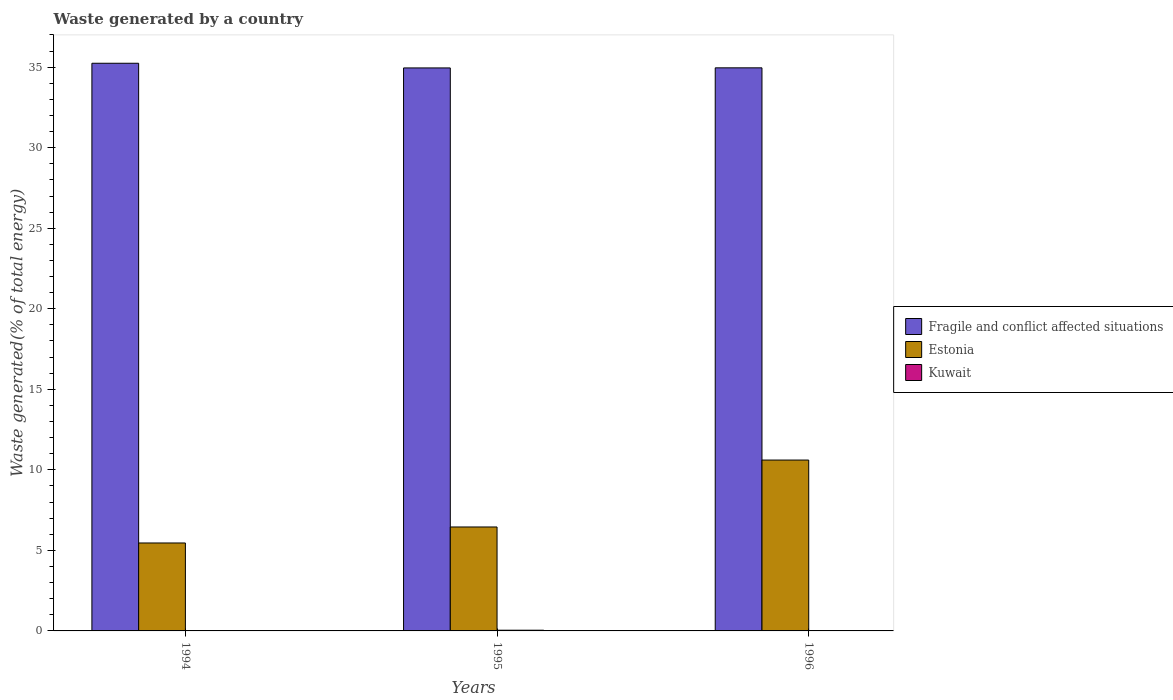Are the number of bars on each tick of the X-axis equal?
Offer a terse response. Yes. In how many cases, is the number of bars for a given year not equal to the number of legend labels?
Give a very brief answer. 0. What is the total waste generated in Fragile and conflict affected situations in 1994?
Your response must be concise. 35.24. Across all years, what is the maximum total waste generated in Fragile and conflict affected situations?
Offer a terse response. 35.24. Across all years, what is the minimum total waste generated in Fragile and conflict affected situations?
Ensure brevity in your answer.  34.95. In which year was the total waste generated in Kuwait minimum?
Your response must be concise. 1994. What is the total total waste generated in Fragile and conflict affected situations in the graph?
Provide a succinct answer. 105.15. What is the difference between the total waste generated in Fragile and conflict affected situations in 1995 and that in 1996?
Keep it short and to the point. -0.01. What is the difference between the total waste generated in Fragile and conflict affected situations in 1996 and the total waste generated in Kuwait in 1994?
Your answer should be compact. 34.94. What is the average total waste generated in Fragile and conflict affected situations per year?
Offer a very short reply. 35.05. In the year 1996, what is the difference between the total waste generated in Estonia and total waste generated in Kuwait?
Provide a short and direct response. 10.58. In how many years, is the total waste generated in Fragile and conflict affected situations greater than 31 %?
Your response must be concise. 3. What is the ratio of the total waste generated in Estonia in 1994 to that in 1996?
Give a very brief answer. 0.51. What is the difference between the highest and the second highest total waste generated in Kuwait?
Offer a very short reply. 0.02. What is the difference between the highest and the lowest total waste generated in Kuwait?
Your answer should be compact. 0.03. In how many years, is the total waste generated in Kuwait greater than the average total waste generated in Kuwait taken over all years?
Your answer should be very brief. 1. What does the 3rd bar from the left in 1996 represents?
Your answer should be compact. Kuwait. What does the 2nd bar from the right in 1996 represents?
Give a very brief answer. Estonia. How many years are there in the graph?
Your answer should be compact. 3. Are the values on the major ticks of Y-axis written in scientific E-notation?
Your answer should be very brief. No. Does the graph contain any zero values?
Offer a very short reply. No. Does the graph contain grids?
Your answer should be compact. No. How many legend labels are there?
Give a very brief answer. 3. What is the title of the graph?
Ensure brevity in your answer.  Waste generated by a country. What is the label or title of the Y-axis?
Make the answer very short. Waste generated(% of total energy). What is the Waste generated(% of total energy) of Fragile and conflict affected situations in 1994?
Give a very brief answer. 35.24. What is the Waste generated(% of total energy) of Estonia in 1994?
Make the answer very short. 5.46. What is the Waste generated(% of total energy) of Kuwait in 1994?
Give a very brief answer. 0.02. What is the Waste generated(% of total energy) in Fragile and conflict affected situations in 1995?
Ensure brevity in your answer.  34.95. What is the Waste generated(% of total energy) of Estonia in 1995?
Your response must be concise. 6.45. What is the Waste generated(% of total energy) in Kuwait in 1995?
Give a very brief answer. 0.04. What is the Waste generated(% of total energy) in Fragile and conflict affected situations in 1996?
Offer a very short reply. 34.96. What is the Waste generated(% of total energy) of Estonia in 1996?
Ensure brevity in your answer.  10.61. What is the Waste generated(% of total energy) in Kuwait in 1996?
Make the answer very short. 0.03. Across all years, what is the maximum Waste generated(% of total energy) of Fragile and conflict affected situations?
Offer a terse response. 35.24. Across all years, what is the maximum Waste generated(% of total energy) of Estonia?
Your response must be concise. 10.61. Across all years, what is the maximum Waste generated(% of total energy) of Kuwait?
Your response must be concise. 0.04. Across all years, what is the minimum Waste generated(% of total energy) in Fragile and conflict affected situations?
Provide a short and direct response. 34.95. Across all years, what is the minimum Waste generated(% of total energy) of Estonia?
Offer a very short reply. 5.46. Across all years, what is the minimum Waste generated(% of total energy) of Kuwait?
Offer a very short reply. 0.02. What is the total Waste generated(% of total energy) of Fragile and conflict affected situations in the graph?
Keep it short and to the point. 105.15. What is the total Waste generated(% of total energy) in Estonia in the graph?
Your answer should be very brief. 22.52. What is the total Waste generated(% of total energy) in Kuwait in the graph?
Offer a very short reply. 0.08. What is the difference between the Waste generated(% of total energy) in Fragile and conflict affected situations in 1994 and that in 1995?
Provide a succinct answer. 0.29. What is the difference between the Waste generated(% of total energy) in Estonia in 1994 and that in 1995?
Provide a short and direct response. -0.99. What is the difference between the Waste generated(% of total energy) of Kuwait in 1994 and that in 1995?
Ensure brevity in your answer.  -0.03. What is the difference between the Waste generated(% of total energy) of Fragile and conflict affected situations in 1994 and that in 1996?
Provide a succinct answer. 0.28. What is the difference between the Waste generated(% of total energy) in Estonia in 1994 and that in 1996?
Your answer should be compact. -5.15. What is the difference between the Waste generated(% of total energy) of Kuwait in 1994 and that in 1996?
Offer a terse response. -0.01. What is the difference between the Waste generated(% of total energy) of Fragile and conflict affected situations in 1995 and that in 1996?
Your answer should be very brief. -0.01. What is the difference between the Waste generated(% of total energy) in Estonia in 1995 and that in 1996?
Give a very brief answer. -4.15. What is the difference between the Waste generated(% of total energy) in Kuwait in 1995 and that in 1996?
Offer a very short reply. 0.02. What is the difference between the Waste generated(% of total energy) in Fragile and conflict affected situations in 1994 and the Waste generated(% of total energy) in Estonia in 1995?
Provide a short and direct response. 28.79. What is the difference between the Waste generated(% of total energy) of Fragile and conflict affected situations in 1994 and the Waste generated(% of total energy) of Kuwait in 1995?
Keep it short and to the point. 35.2. What is the difference between the Waste generated(% of total energy) in Estonia in 1994 and the Waste generated(% of total energy) in Kuwait in 1995?
Your response must be concise. 5.42. What is the difference between the Waste generated(% of total energy) in Fragile and conflict affected situations in 1994 and the Waste generated(% of total energy) in Estonia in 1996?
Your response must be concise. 24.63. What is the difference between the Waste generated(% of total energy) of Fragile and conflict affected situations in 1994 and the Waste generated(% of total energy) of Kuwait in 1996?
Your answer should be compact. 35.22. What is the difference between the Waste generated(% of total energy) of Estonia in 1994 and the Waste generated(% of total energy) of Kuwait in 1996?
Provide a short and direct response. 5.43. What is the difference between the Waste generated(% of total energy) in Fragile and conflict affected situations in 1995 and the Waste generated(% of total energy) in Estonia in 1996?
Give a very brief answer. 24.34. What is the difference between the Waste generated(% of total energy) of Fragile and conflict affected situations in 1995 and the Waste generated(% of total energy) of Kuwait in 1996?
Your answer should be compact. 34.93. What is the difference between the Waste generated(% of total energy) of Estonia in 1995 and the Waste generated(% of total energy) of Kuwait in 1996?
Ensure brevity in your answer.  6.43. What is the average Waste generated(% of total energy) in Fragile and conflict affected situations per year?
Your answer should be compact. 35.05. What is the average Waste generated(% of total energy) of Estonia per year?
Your answer should be compact. 7.51. What is the average Waste generated(% of total energy) of Kuwait per year?
Your answer should be very brief. 0.03. In the year 1994, what is the difference between the Waste generated(% of total energy) of Fragile and conflict affected situations and Waste generated(% of total energy) of Estonia?
Offer a terse response. 29.78. In the year 1994, what is the difference between the Waste generated(% of total energy) in Fragile and conflict affected situations and Waste generated(% of total energy) in Kuwait?
Provide a short and direct response. 35.23. In the year 1994, what is the difference between the Waste generated(% of total energy) of Estonia and Waste generated(% of total energy) of Kuwait?
Provide a succinct answer. 5.44. In the year 1995, what is the difference between the Waste generated(% of total energy) in Fragile and conflict affected situations and Waste generated(% of total energy) in Estonia?
Provide a short and direct response. 28.5. In the year 1995, what is the difference between the Waste generated(% of total energy) in Fragile and conflict affected situations and Waste generated(% of total energy) in Kuwait?
Provide a succinct answer. 34.91. In the year 1995, what is the difference between the Waste generated(% of total energy) in Estonia and Waste generated(% of total energy) in Kuwait?
Provide a succinct answer. 6.41. In the year 1996, what is the difference between the Waste generated(% of total energy) of Fragile and conflict affected situations and Waste generated(% of total energy) of Estonia?
Offer a terse response. 24.35. In the year 1996, what is the difference between the Waste generated(% of total energy) in Fragile and conflict affected situations and Waste generated(% of total energy) in Kuwait?
Offer a terse response. 34.93. In the year 1996, what is the difference between the Waste generated(% of total energy) of Estonia and Waste generated(% of total energy) of Kuwait?
Your answer should be compact. 10.58. What is the ratio of the Waste generated(% of total energy) in Fragile and conflict affected situations in 1994 to that in 1995?
Ensure brevity in your answer.  1.01. What is the ratio of the Waste generated(% of total energy) of Estonia in 1994 to that in 1995?
Make the answer very short. 0.85. What is the ratio of the Waste generated(% of total energy) of Kuwait in 1994 to that in 1995?
Your answer should be compact. 0.34. What is the ratio of the Waste generated(% of total energy) of Estonia in 1994 to that in 1996?
Your answer should be compact. 0.51. What is the ratio of the Waste generated(% of total energy) in Kuwait in 1994 to that in 1996?
Offer a terse response. 0.61. What is the ratio of the Waste generated(% of total energy) of Fragile and conflict affected situations in 1995 to that in 1996?
Your answer should be compact. 1. What is the ratio of the Waste generated(% of total energy) in Estonia in 1995 to that in 1996?
Keep it short and to the point. 0.61. What is the ratio of the Waste generated(% of total energy) of Kuwait in 1995 to that in 1996?
Offer a terse response. 1.77. What is the difference between the highest and the second highest Waste generated(% of total energy) in Fragile and conflict affected situations?
Ensure brevity in your answer.  0.28. What is the difference between the highest and the second highest Waste generated(% of total energy) of Estonia?
Your response must be concise. 4.15. What is the difference between the highest and the second highest Waste generated(% of total energy) in Kuwait?
Offer a very short reply. 0.02. What is the difference between the highest and the lowest Waste generated(% of total energy) in Fragile and conflict affected situations?
Ensure brevity in your answer.  0.29. What is the difference between the highest and the lowest Waste generated(% of total energy) in Estonia?
Offer a terse response. 5.15. What is the difference between the highest and the lowest Waste generated(% of total energy) of Kuwait?
Offer a terse response. 0.03. 